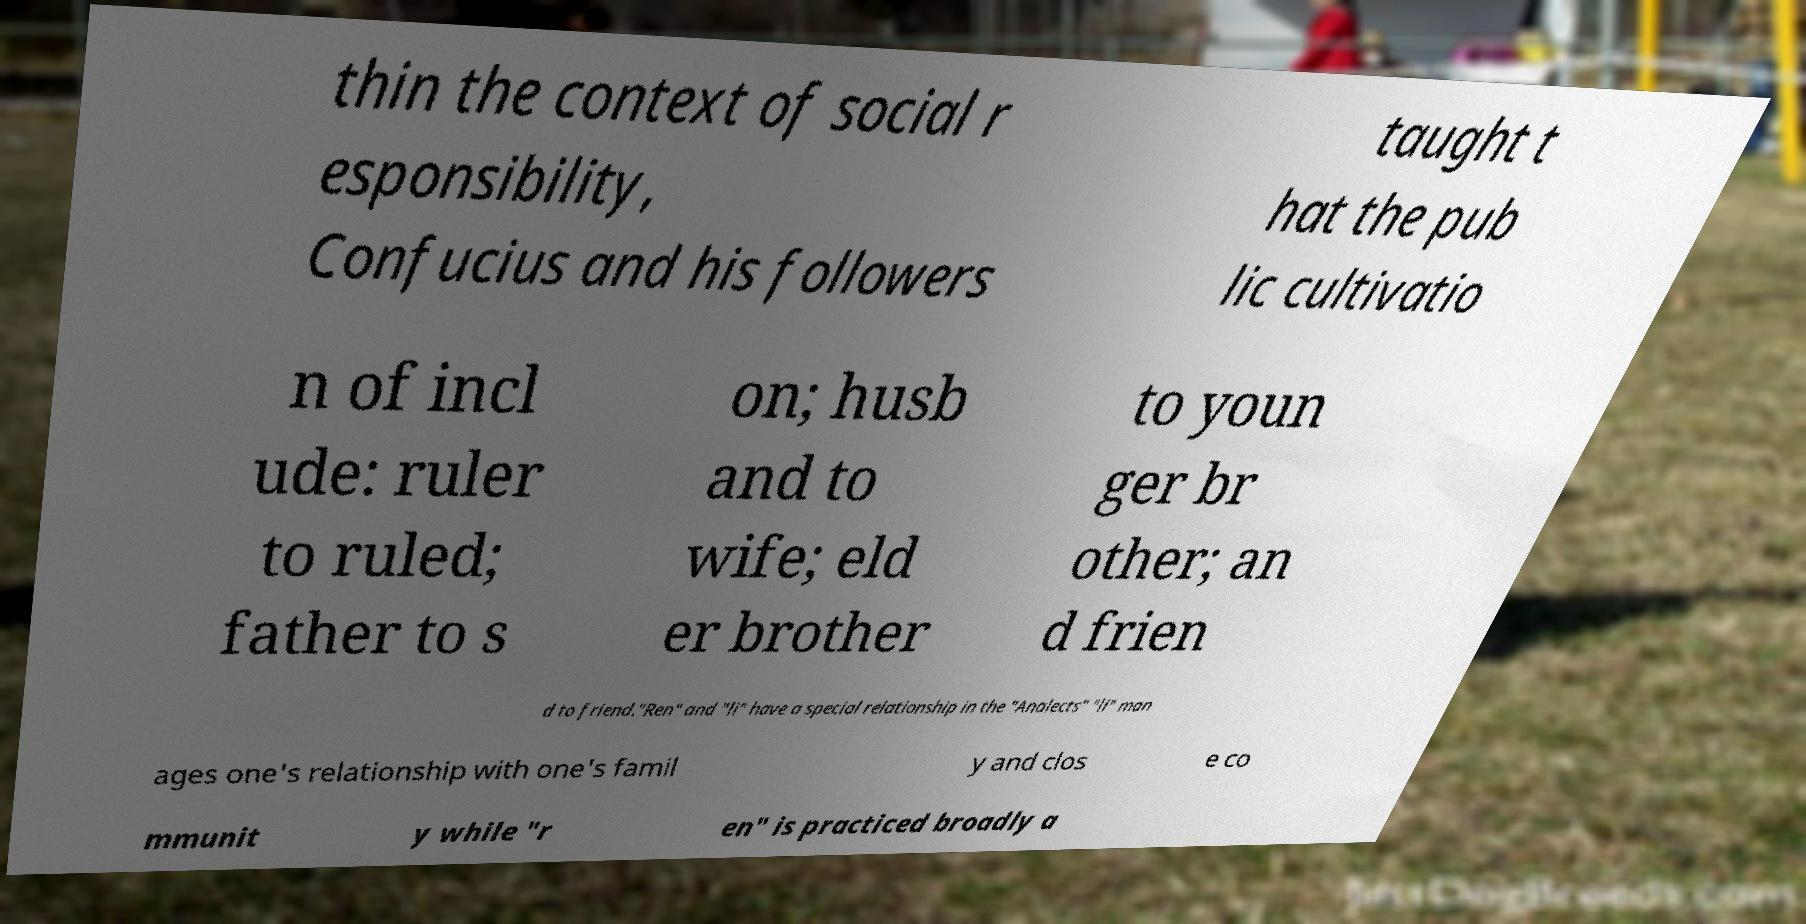Could you assist in decoding the text presented in this image and type it out clearly? thin the context of social r esponsibility, Confucius and his followers taught t hat the pub lic cultivatio n of incl ude: ruler to ruled; father to s on; husb and to wife; eld er brother to youn ger br other; an d frien d to friend."Ren" and "li" have a special relationship in the "Analects" "li" man ages one's relationship with one's famil y and clos e co mmunit y while "r en" is practiced broadly a 